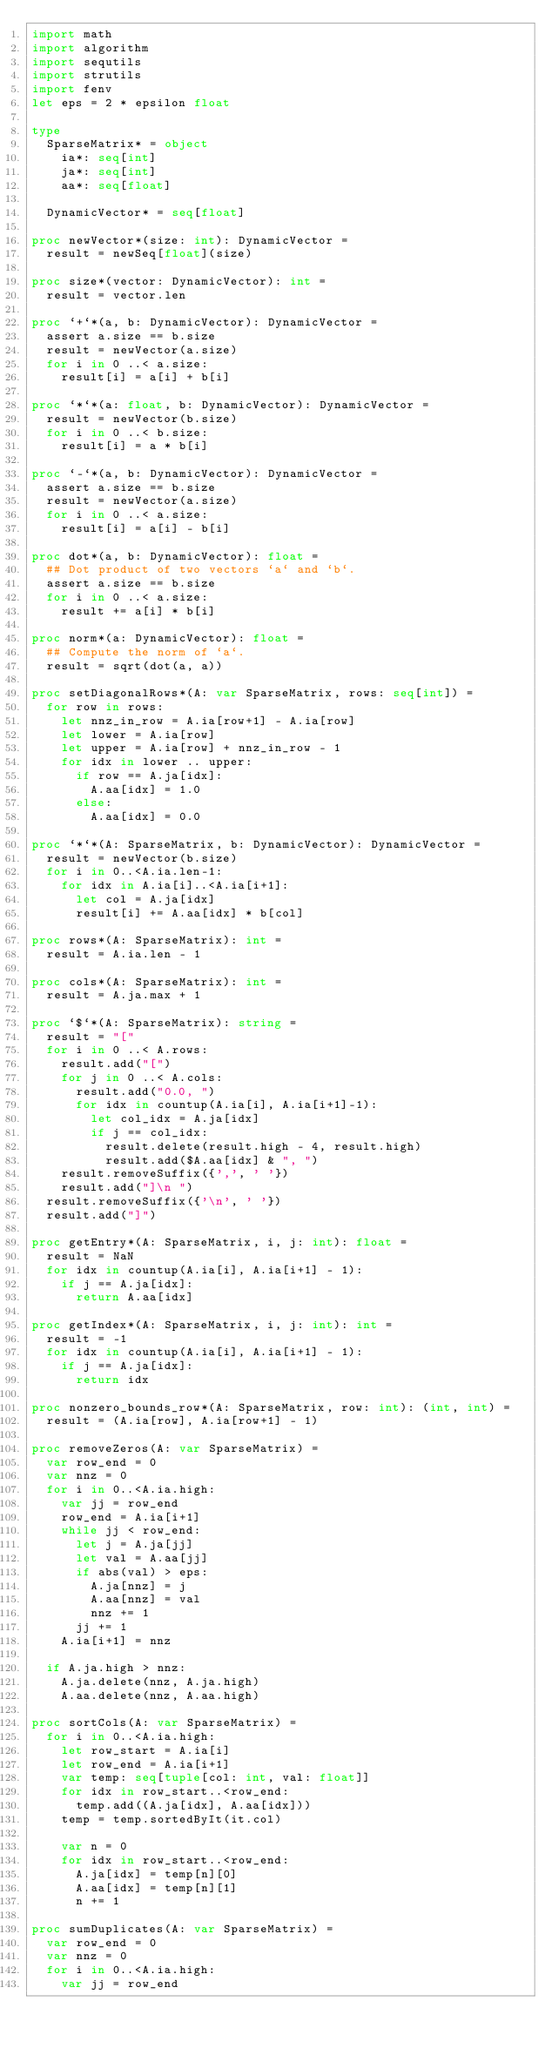Convert code to text. <code><loc_0><loc_0><loc_500><loc_500><_Nim_>import math
import algorithm
import sequtils
import strutils
import fenv
let eps = 2 * epsilon float

type
  SparseMatrix* = object
    ia*: seq[int]
    ja*: seq[int]
    aa*: seq[float]

  DynamicVector* = seq[float]

proc newVector*(size: int): DynamicVector =
  result = newSeq[float](size)

proc size*(vector: DynamicVector): int =
  result = vector.len

proc `+`*(a, b: DynamicVector): DynamicVector =
  assert a.size == b.size
  result = newVector(a.size)
  for i in 0 ..< a.size:
    result[i] = a[i] + b[i]

proc `*`*(a: float, b: DynamicVector): DynamicVector =
  result = newVector(b.size)
  for i in 0 ..< b.size:
    result[i] = a * b[i]

proc `-`*(a, b: DynamicVector): DynamicVector =
  assert a.size == b.size
  result = newVector(a.size)
  for i in 0 ..< a.size:
    result[i] = a[i] - b[i]

proc dot*(a, b: DynamicVector): float =
  ## Dot product of two vectors `a` and `b`.
  assert a.size == b.size
  for i in 0 ..< a.size:
    result += a[i] * b[i]

proc norm*(a: DynamicVector): float =
  ## Compute the norm of `a`.
  result = sqrt(dot(a, a))

proc setDiagonalRows*(A: var SparseMatrix, rows: seq[int]) =
  for row in rows:
    let nnz_in_row = A.ia[row+1] - A.ia[row]
    let lower = A.ia[row]
    let upper = A.ia[row] + nnz_in_row - 1
    for idx in lower .. upper:
      if row == A.ja[idx]:
        A.aa[idx] = 1.0
      else:
        A.aa[idx] = 0.0

proc `*`*(A: SparseMatrix, b: DynamicVector): DynamicVector =
  result = newVector(b.size)
  for i in 0..<A.ia.len-1:
    for idx in A.ia[i]..<A.ia[i+1]:
      let col = A.ja[idx]
      result[i] += A.aa[idx] * b[col]

proc rows*(A: SparseMatrix): int =
  result = A.ia.len - 1

proc cols*(A: SparseMatrix): int =
  result = A.ja.max + 1

proc `$`*(A: SparseMatrix): string =
  result = "["
  for i in 0 ..< A.rows:
    result.add("[")
    for j in 0 ..< A.cols:
      result.add("0.0, ")
      for idx in countup(A.ia[i], A.ia[i+1]-1):
        let col_idx = A.ja[idx]
        if j == col_idx:
          result.delete(result.high - 4, result.high)
          result.add($A.aa[idx] & ", ")
    result.removeSuffix({',', ' '})
    result.add("]\n ")
  result.removeSuffix({'\n', ' '})
  result.add("]")

proc getEntry*(A: SparseMatrix, i, j: int): float =
  result = NaN
  for idx in countup(A.ia[i], A.ia[i+1] - 1):
    if j == A.ja[idx]:
      return A.aa[idx]

proc getIndex*(A: SparseMatrix, i, j: int): int =
  result = -1
  for idx in countup(A.ia[i], A.ia[i+1] - 1):
    if j == A.ja[idx]:
      return idx

proc nonzero_bounds_row*(A: SparseMatrix, row: int): (int, int) =
  result = (A.ia[row], A.ia[row+1] - 1)

proc removeZeros(A: var SparseMatrix) =
  var row_end = 0
  var nnz = 0
  for i in 0..<A.ia.high:
    var jj = row_end
    row_end = A.ia[i+1]
    while jj < row_end:
      let j = A.ja[jj]
      let val = A.aa[jj]
      if abs(val) > eps:
        A.ja[nnz] = j
        A.aa[nnz] = val
        nnz += 1
      jj += 1
    A.ia[i+1] = nnz

  if A.ja.high > nnz:
    A.ja.delete(nnz, A.ja.high)
    A.aa.delete(nnz, A.aa.high)

proc sortCols(A: var SparseMatrix) =
  for i in 0..<A.ia.high:
    let row_start = A.ia[i]
    let row_end = A.ia[i+1]
    var temp: seq[tuple[col: int, val: float]]
    for idx in row_start..<row_end:
      temp.add((A.ja[idx], A.aa[idx]))
    temp = temp.sortedByIt(it.col)

    var n = 0
    for idx in row_start..<row_end:
      A.ja[idx] = temp[n][0]
      A.aa[idx] = temp[n][1]
      n += 1

proc sumDuplicates(A: var SparseMatrix) =
  var row_end = 0
  var nnz = 0
  for i in 0..<A.ia.high:
    var jj = row_end</code> 